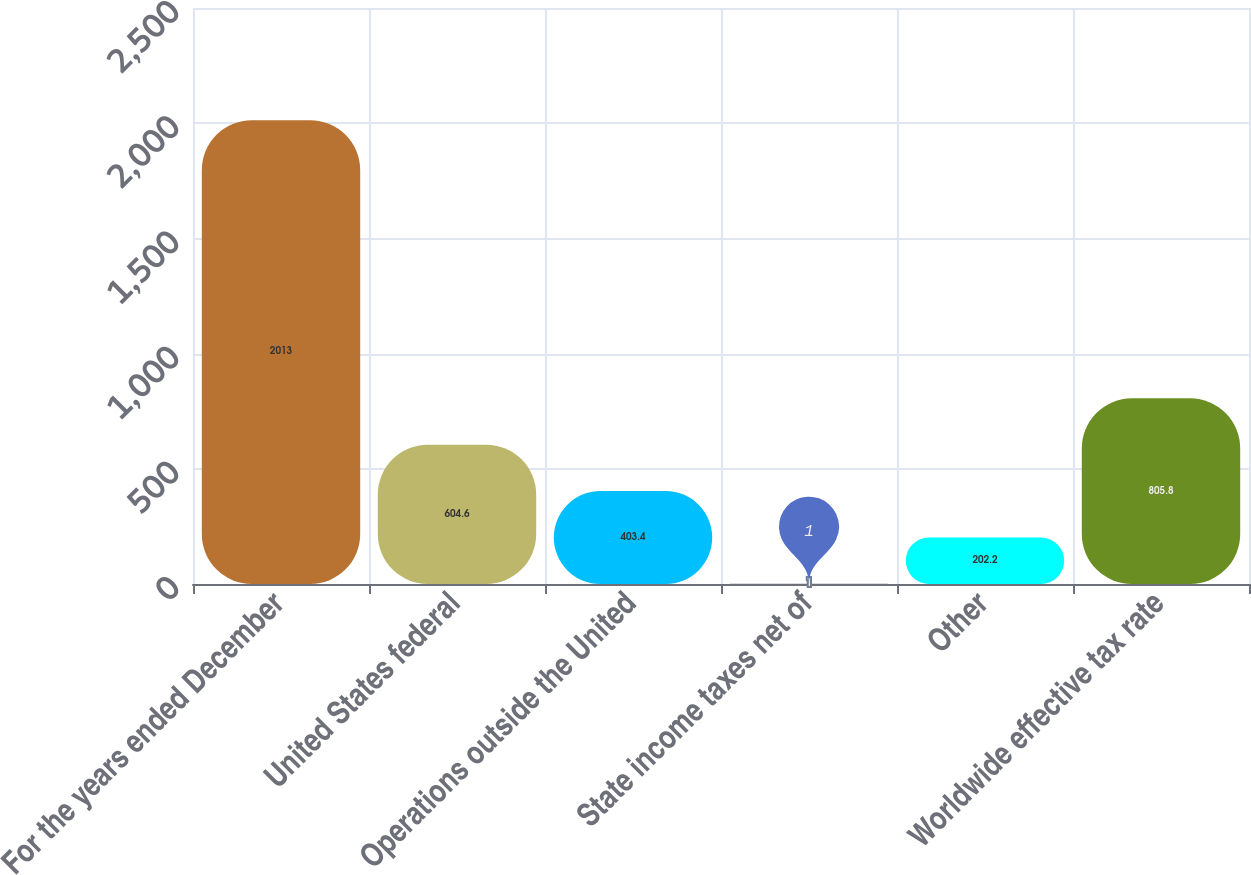Convert chart to OTSL. <chart><loc_0><loc_0><loc_500><loc_500><bar_chart><fcel>For the years ended December<fcel>United States federal<fcel>Operations outside the United<fcel>State income taxes net of<fcel>Other<fcel>Worldwide effective tax rate<nl><fcel>2013<fcel>604.6<fcel>403.4<fcel>1<fcel>202.2<fcel>805.8<nl></chart> 